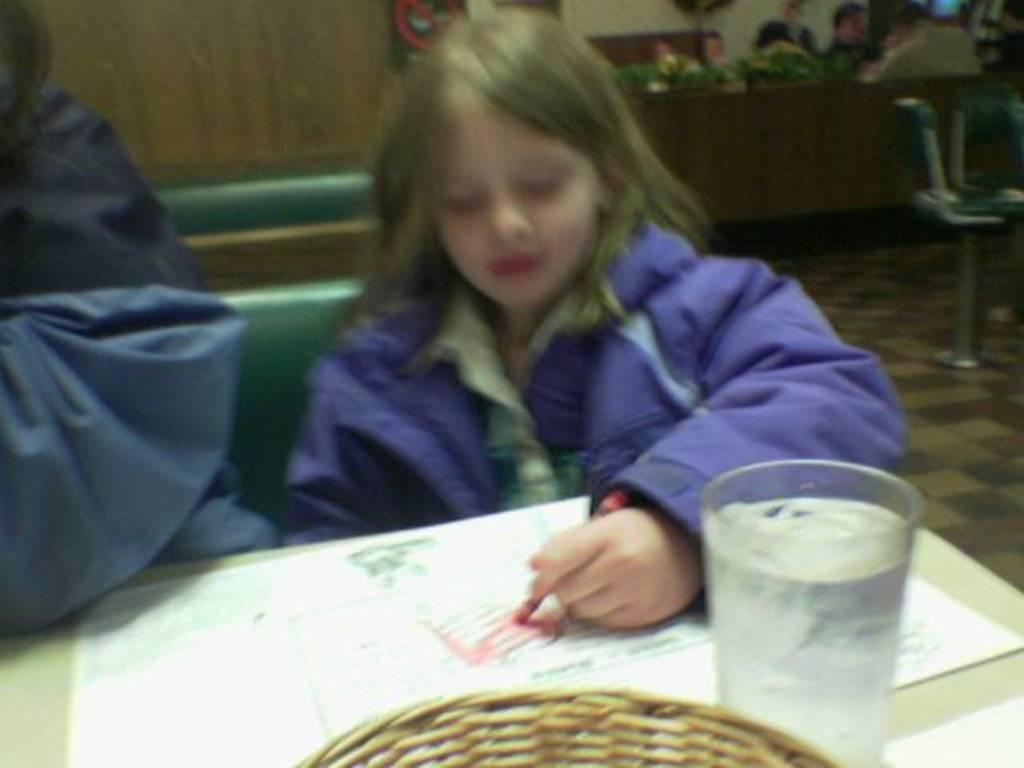Who is the main subject in the image? There is a girl in the image. What is the girl doing in the image? The girl is drawing. Are there any other people in the image? Yes, there are people sitting on chairs on the right side of the image. What type of shoes is the squirrel wearing in the image? There is no squirrel present in the image, and therefore no shoes to describe. 